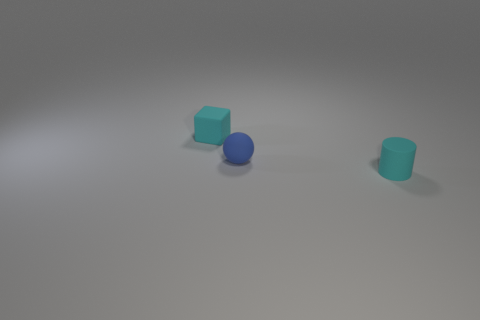Add 2 small cylinders. How many objects exist? 5 Subtract all cubes. How many objects are left? 2 Add 1 small matte spheres. How many small matte spheres exist? 2 Subtract 0 cyan spheres. How many objects are left? 3 Subtract all tiny cyan cubes. Subtract all tiny gray rubber blocks. How many objects are left? 2 Add 1 cyan things. How many cyan things are left? 3 